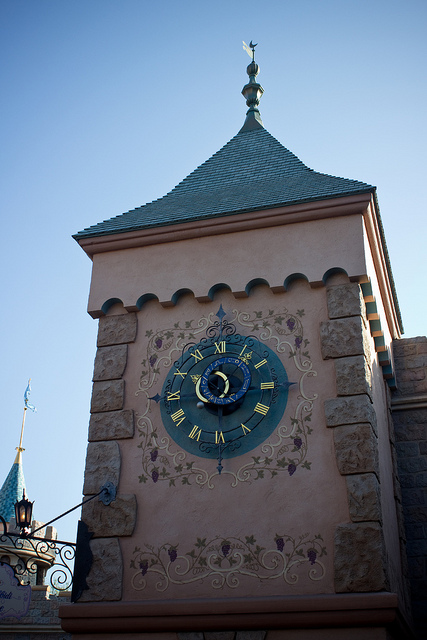<image>What time does it say on the clock? It is unsure what time it says on the clock. Is this a church? I'm not sure if this is a church. There are conflicting answers. Is this a church? I am not sure if this is a church. It can be both a church and not a church. What time does it say on the clock? I am not sure what time it says on the clock. It can be seen '8:45', '1', '10:30', '8:50', '12:50', '9:30', '10:06', or '11:10'. 